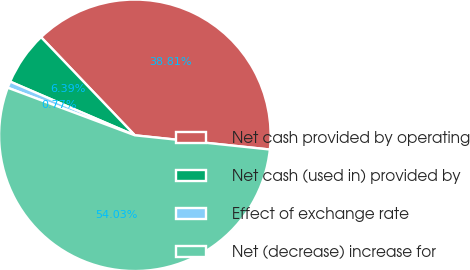Convert chart to OTSL. <chart><loc_0><loc_0><loc_500><loc_500><pie_chart><fcel>Net cash provided by operating<fcel>Net cash (used in) provided by<fcel>Effect of exchange rate<fcel>Net (decrease) increase for<nl><fcel>38.81%<fcel>6.39%<fcel>0.77%<fcel>54.03%<nl></chart> 